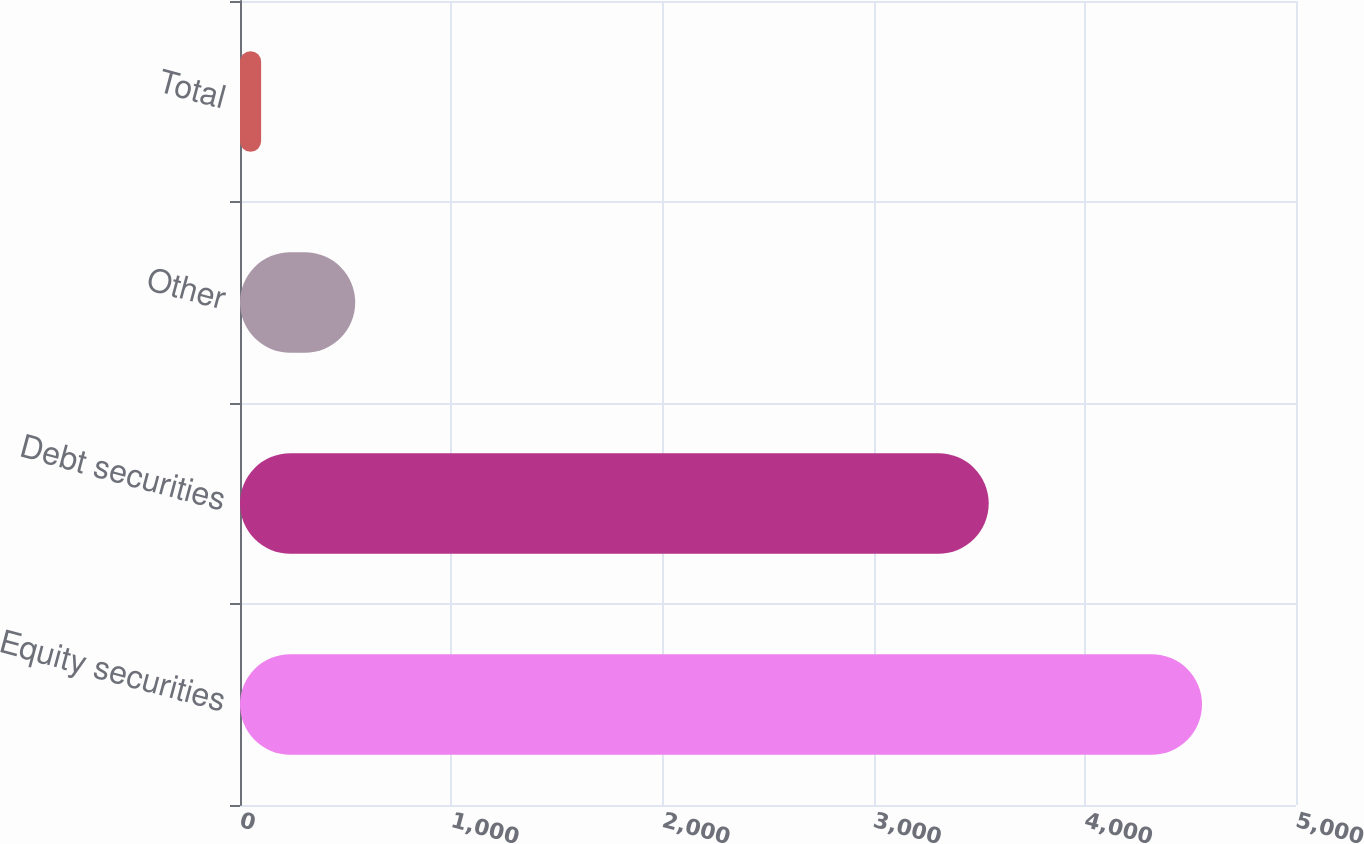Convert chart. <chart><loc_0><loc_0><loc_500><loc_500><bar_chart><fcel>Equity securities<fcel>Debt securities<fcel>Other<fcel>Total<nl><fcel>4555<fcel>3545<fcel>545.5<fcel>100<nl></chart> 